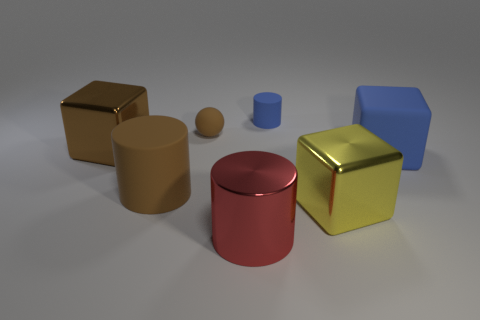Add 1 big metal things. How many objects exist? 8 Subtract all balls. How many objects are left? 6 Add 1 rubber balls. How many rubber balls exist? 2 Subtract 1 brown cubes. How many objects are left? 6 Subtract all small cyan cylinders. Subtract all brown cylinders. How many objects are left? 6 Add 1 small matte cylinders. How many small matte cylinders are left? 2 